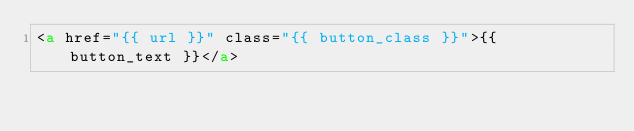<code> <loc_0><loc_0><loc_500><loc_500><_HTML_><a href="{{ url }}" class="{{ button_class }}">{{ button_text }}</a></code> 